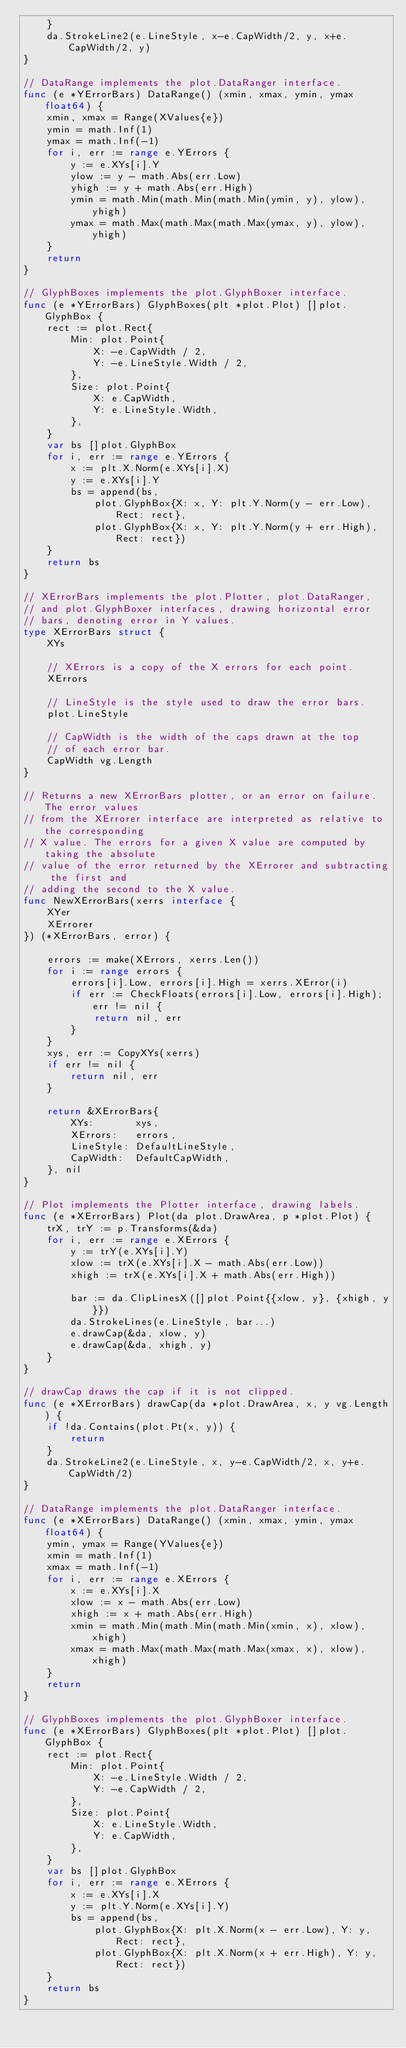<code> <loc_0><loc_0><loc_500><loc_500><_Go_>	}
	da.StrokeLine2(e.LineStyle, x-e.CapWidth/2, y, x+e.CapWidth/2, y)
}

// DataRange implements the plot.DataRanger interface.
func (e *YErrorBars) DataRange() (xmin, xmax, ymin, ymax float64) {
	xmin, xmax = Range(XValues{e})
	ymin = math.Inf(1)
	ymax = math.Inf(-1)
	for i, err := range e.YErrors {
		y := e.XYs[i].Y
		ylow := y - math.Abs(err.Low)
		yhigh := y + math.Abs(err.High)
		ymin = math.Min(math.Min(math.Min(ymin, y), ylow), yhigh)
		ymax = math.Max(math.Max(math.Max(ymax, y), ylow), yhigh)
	}
	return
}

// GlyphBoxes implements the plot.GlyphBoxer interface.
func (e *YErrorBars) GlyphBoxes(plt *plot.Plot) []plot.GlyphBox {
	rect := plot.Rect{
		Min: plot.Point{
			X: -e.CapWidth / 2,
			Y: -e.LineStyle.Width / 2,
		},
		Size: plot.Point{
			X: e.CapWidth,
			Y: e.LineStyle.Width,
		},
	}
	var bs []plot.GlyphBox
	for i, err := range e.YErrors {
		x := plt.X.Norm(e.XYs[i].X)
		y := e.XYs[i].Y
		bs = append(bs,
			plot.GlyphBox{X: x, Y: plt.Y.Norm(y - err.Low), Rect: rect},
			plot.GlyphBox{X: x, Y: plt.Y.Norm(y + err.High), Rect: rect})
	}
	return bs
}

// XErrorBars implements the plot.Plotter, plot.DataRanger,
// and plot.GlyphBoxer interfaces, drawing horizontal error
// bars, denoting error in Y values.
type XErrorBars struct {
	XYs

	// XErrors is a copy of the X errors for each point.
	XErrors

	// LineStyle is the style used to draw the error bars.
	plot.LineStyle

	// CapWidth is the width of the caps drawn at the top
	// of each error bar.
	CapWidth vg.Length
}

// Returns a new XErrorBars plotter, or an error on failure. The error values
// from the XErrorer interface are interpreted as relative to the corresponding
// X value. The errors for a given X value are computed by taking the absolute
// value of the error returned by the XErrorer and subtracting the first and
// adding the second to the X value.
func NewXErrorBars(xerrs interface {
	XYer
	XErrorer
}) (*XErrorBars, error) {

	errors := make(XErrors, xerrs.Len())
	for i := range errors {
		errors[i].Low, errors[i].High = xerrs.XError(i)
		if err := CheckFloats(errors[i].Low, errors[i].High); err != nil {
			return nil, err
		}
	}
	xys, err := CopyXYs(xerrs)
	if err != nil {
		return nil, err
	}

	return &XErrorBars{
		XYs:       xys,
		XErrors:   errors,
		LineStyle: DefaultLineStyle,
		CapWidth:  DefaultCapWidth,
	}, nil
}

// Plot implements the Plotter interface, drawing labels.
func (e *XErrorBars) Plot(da plot.DrawArea, p *plot.Plot) {
	trX, trY := p.Transforms(&da)
	for i, err := range e.XErrors {
		y := trY(e.XYs[i].Y)
		xlow := trX(e.XYs[i].X - math.Abs(err.Low))
		xhigh := trX(e.XYs[i].X + math.Abs(err.High))

		bar := da.ClipLinesX([]plot.Point{{xlow, y}, {xhigh, y}})
		da.StrokeLines(e.LineStyle, bar...)
		e.drawCap(&da, xlow, y)
		e.drawCap(&da, xhigh, y)
	}
}

// drawCap draws the cap if it is not clipped.
func (e *XErrorBars) drawCap(da *plot.DrawArea, x, y vg.Length) {
	if !da.Contains(plot.Pt(x, y)) {
		return
	}
	da.StrokeLine2(e.LineStyle, x, y-e.CapWidth/2, x, y+e.CapWidth/2)
}

// DataRange implements the plot.DataRanger interface.
func (e *XErrorBars) DataRange() (xmin, xmax, ymin, ymax float64) {
	ymin, ymax = Range(YValues{e})
	xmin = math.Inf(1)
	xmax = math.Inf(-1)
	for i, err := range e.XErrors {
		x := e.XYs[i].X
		xlow := x - math.Abs(err.Low)
		xhigh := x + math.Abs(err.High)
		xmin = math.Min(math.Min(math.Min(xmin, x), xlow), xhigh)
		xmax = math.Max(math.Max(math.Max(xmax, x), xlow), xhigh)
	}
	return
}

// GlyphBoxes implements the plot.GlyphBoxer interface.
func (e *XErrorBars) GlyphBoxes(plt *plot.Plot) []plot.GlyphBox {
	rect := plot.Rect{
		Min: plot.Point{
			X: -e.LineStyle.Width / 2,
			Y: -e.CapWidth / 2,
		},
		Size: plot.Point{
			X: e.LineStyle.Width,
			Y: e.CapWidth,
		},
	}
	var bs []plot.GlyphBox
	for i, err := range e.XErrors {
		x := e.XYs[i].X
		y := plt.Y.Norm(e.XYs[i].Y)
		bs = append(bs,
			plot.GlyphBox{X: plt.X.Norm(x - err.Low), Y: y, Rect: rect},
			plot.GlyphBox{X: plt.X.Norm(x + err.High), Y: y, Rect: rect})
	}
	return bs
}
</code> 